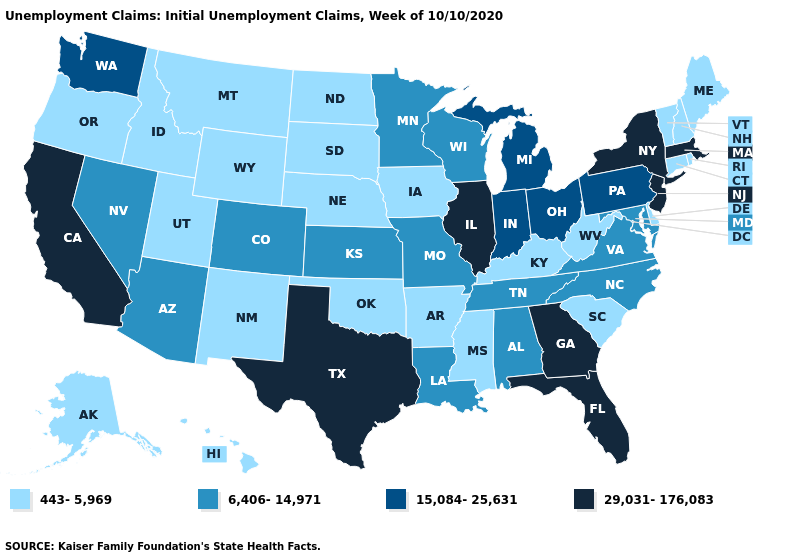What is the value of Utah?
Answer briefly. 443-5,969. Name the states that have a value in the range 443-5,969?
Write a very short answer. Alaska, Arkansas, Connecticut, Delaware, Hawaii, Idaho, Iowa, Kentucky, Maine, Mississippi, Montana, Nebraska, New Hampshire, New Mexico, North Dakota, Oklahoma, Oregon, Rhode Island, South Carolina, South Dakota, Utah, Vermont, West Virginia, Wyoming. Among the states that border Connecticut , which have the highest value?
Concise answer only. Massachusetts, New York. What is the value of Arkansas?
Keep it brief. 443-5,969. How many symbols are there in the legend?
Answer briefly. 4. Among the states that border New Hampshire , does Vermont have the highest value?
Be succinct. No. What is the lowest value in states that border South Dakota?
Answer briefly. 443-5,969. Name the states that have a value in the range 29,031-176,083?
Keep it brief. California, Florida, Georgia, Illinois, Massachusetts, New Jersey, New York, Texas. How many symbols are there in the legend?
Answer briefly. 4. Which states have the highest value in the USA?
Answer briefly. California, Florida, Georgia, Illinois, Massachusetts, New Jersey, New York, Texas. What is the value of Minnesota?
Answer briefly. 6,406-14,971. What is the highest value in the USA?
Quick response, please. 29,031-176,083. What is the highest value in the South ?
Write a very short answer. 29,031-176,083. Among the states that border Florida , does Alabama have the lowest value?
Give a very brief answer. Yes. Which states have the lowest value in the USA?
Write a very short answer. Alaska, Arkansas, Connecticut, Delaware, Hawaii, Idaho, Iowa, Kentucky, Maine, Mississippi, Montana, Nebraska, New Hampshire, New Mexico, North Dakota, Oklahoma, Oregon, Rhode Island, South Carolina, South Dakota, Utah, Vermont, West Virginia, Wyoming. 